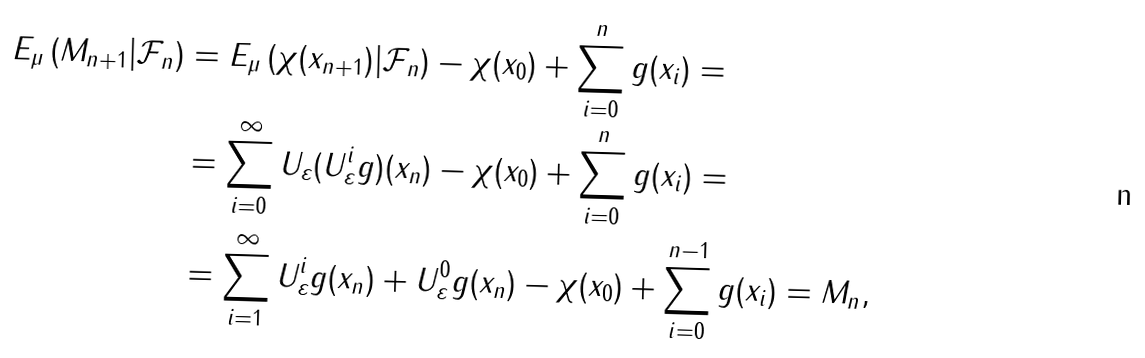<formula> <loc_0><loc_0><loc_500><loc_500>E _ { \mu } \left ( M _ { n + 1 } | \mathcal { F } _ { n } \right ) & = E _ { \mu } \left ( \chi ( x _ { n + 1 } ) | \mathcal { F } _ { n } \right ) - \chi ( x _ { 0 } ) + \sum _ { i = 0 } ^ { n } g ( x _ { i } ) = \\ & = \sum _ { i = 0 } ^ { \infty } U _ { \varepsilon } ( U ^ { i } _ { \varepsilon } g ) ( x _ { n } ) - \chi ( x _ { 0 } ) + \sum _ { i = 0 } ^ { n } g ( x _ { i } ) = \\ & = \sum _ { i = 1 } ^ { \infty } U ^ { i } _ { \varepsilon } g ( x _ { n } ) + U _ { \varepsilon } ^ { 0 } g ( x _ { n } ) - \chi ( x _ { 0 } ) + \sum _ { i = 0 } ^ { n - 1 } g ( x _ { i } ) = M _ { n } ,</formula> 